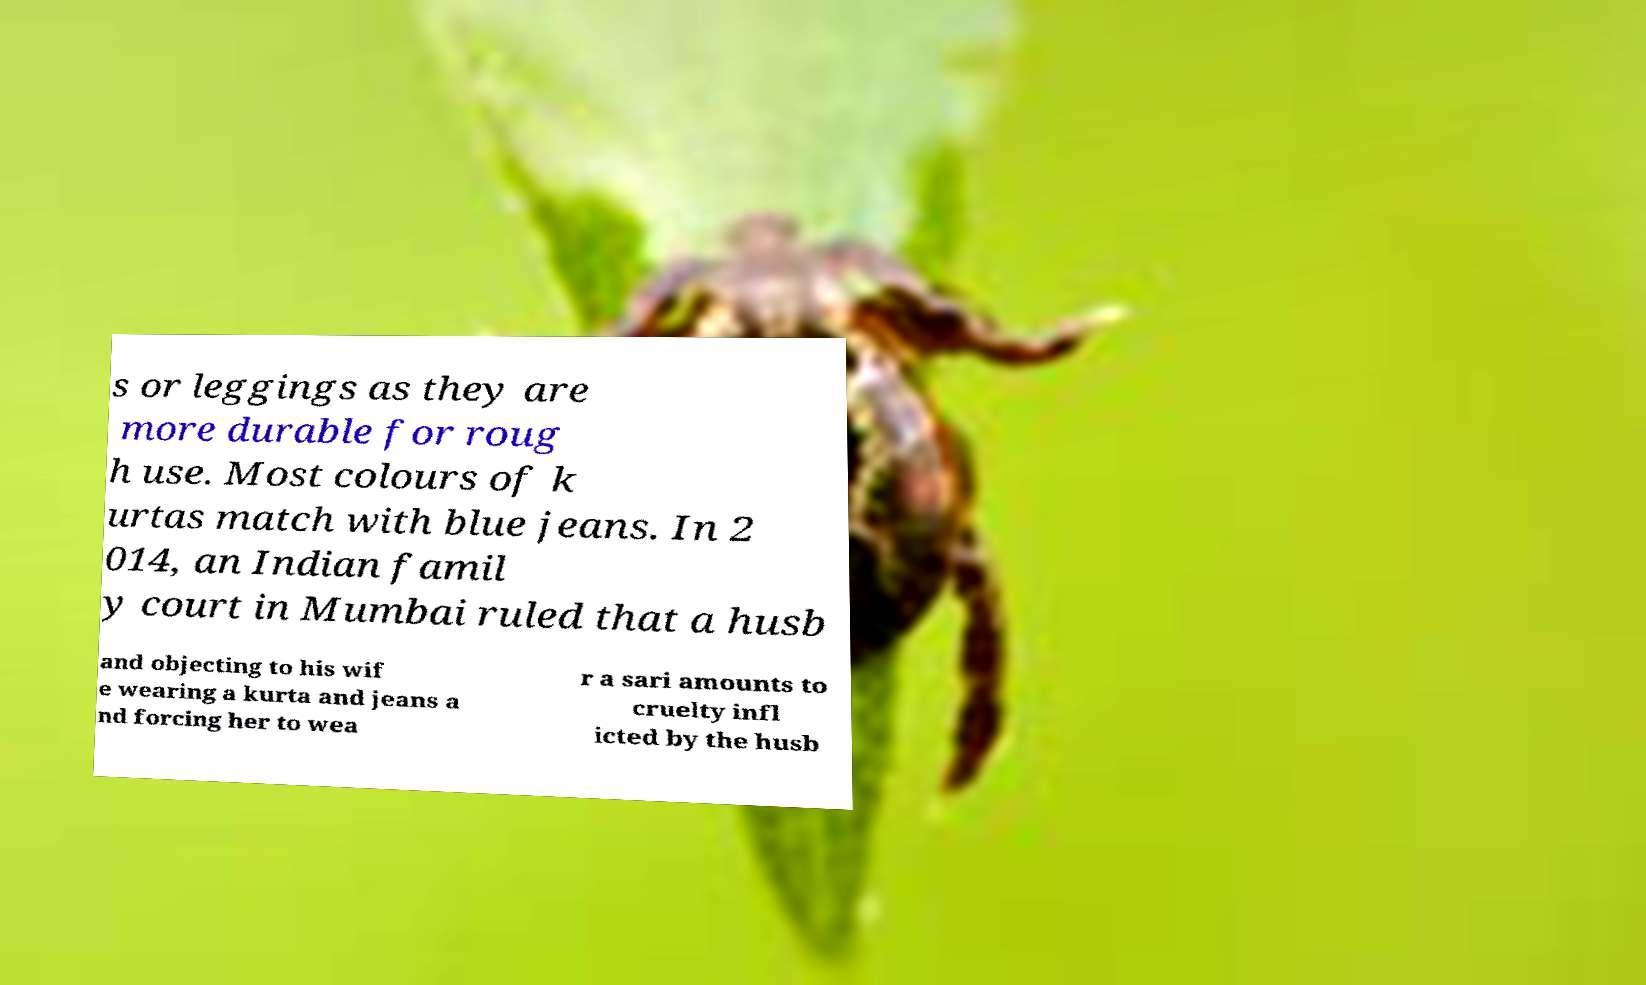Could you extract and type out the text from this image? s or leggings as they are more durable for roug h use. Most colours of k urtas match with blue jeans. In 2 014, an Indian famil y court in Mumbai ruled that a husb and objecting to his wif e wearing a kurta and jeans a nd forcing her to wea r a sari amounts to cruelty infl icted by the husb 